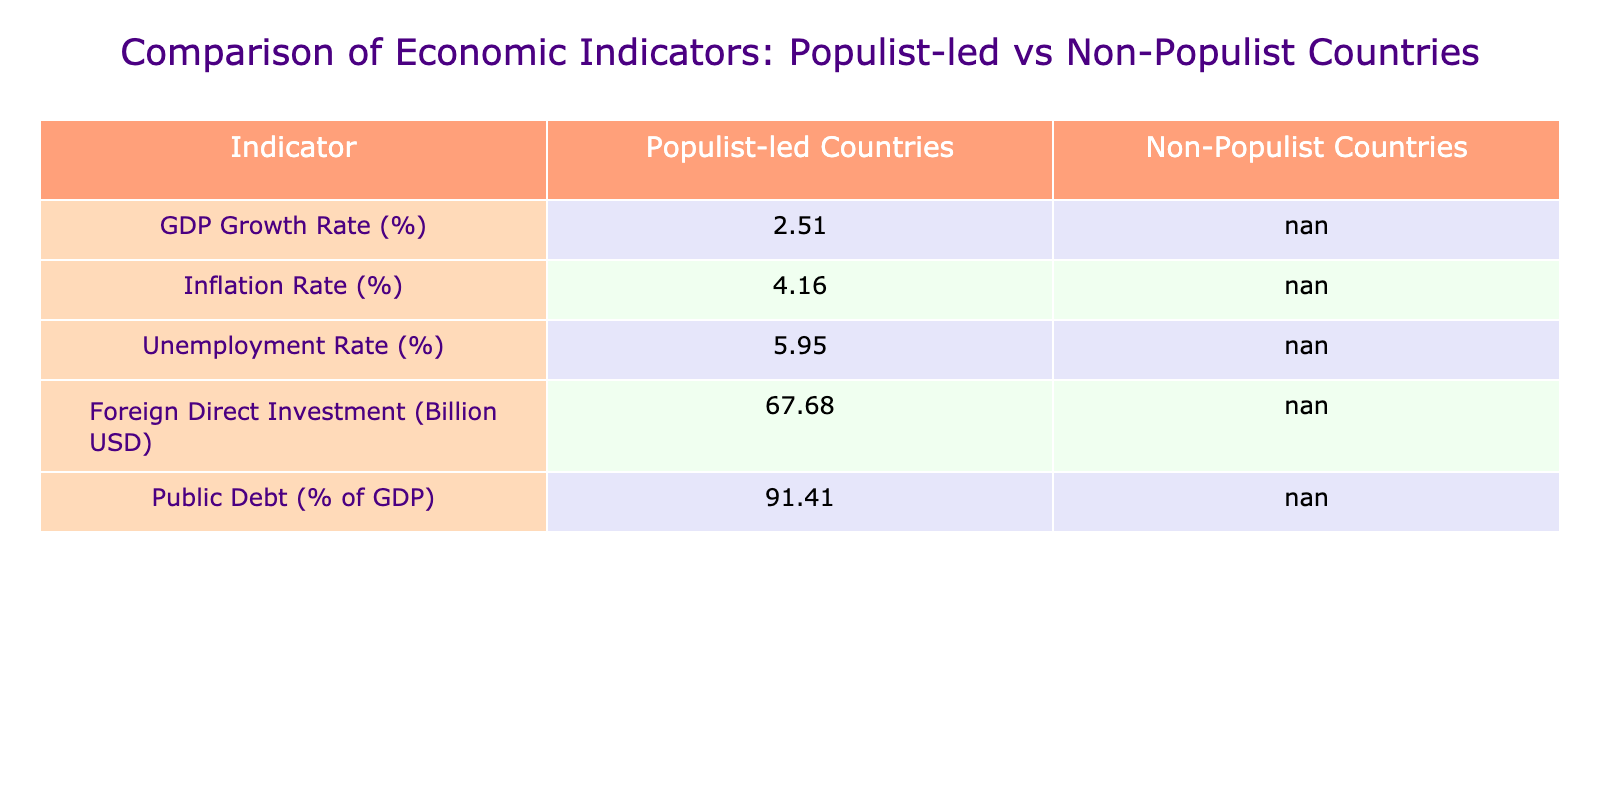What is the average GDP growth rate for populist-led countries? To calculate the average GDP growth rate, I will sum the GDP growth rates of all populist-led countries: (2.9 + 4.6 + 3.1 + 4.5) = 15.1. There are 4 populist-led countries, so the average is 15.1 / 4 = 3.775. Rounding to two decimal places gives 3.78.
Answer: 3.78 What is the inflation rate of the United States? The inflation rate for the United States is directly listed in the table. It is 1.4%.
Answer: 1.4% True or False: The unemployment rate is lower in non-populist countries compared to populist countries. To determine this, I need to compare the average unemployment rates of both groups. The average unemployment rate for populist countries is (11.2 + 3.6 + 13.4 + 3.2) / 4 = 7.85%, while the average for non-populist countries is (3.6 + 3.1 + 5.7 + 8.1 + 2.4 + 5.2) / 6 = 4.23%. Since 7.85% > 4.23%, the statement is false.
Answer: False What is the difference in foreign direct investment between populist-led and non-populist-led countries? The average foreign direct investment for populist countries is (78.6 + 5.2 + 12.5 + 24.8) / 4 = 30.52 billion USD. For non-populist countries, it is (354.8 + 36.5 + 50.6 + 59.9 + 14.5 + 39.4) / 6 = 85.5 billion USD. The difference is calculated as 85.5 - 30.52 = 54.98 billion USD.
Answer: 54.98 billion USD What is the highest public debt percentage among populist-led countries? To find the highest public debt percentage, I compare the values for each populist-led country: Brazil is at 88.9%, Hungary is at 76.8%, Turkey is at 42.8%, and Poland is at 57.5%. The highest value is 88.9% from Brazil.
Answer: 88.9% 